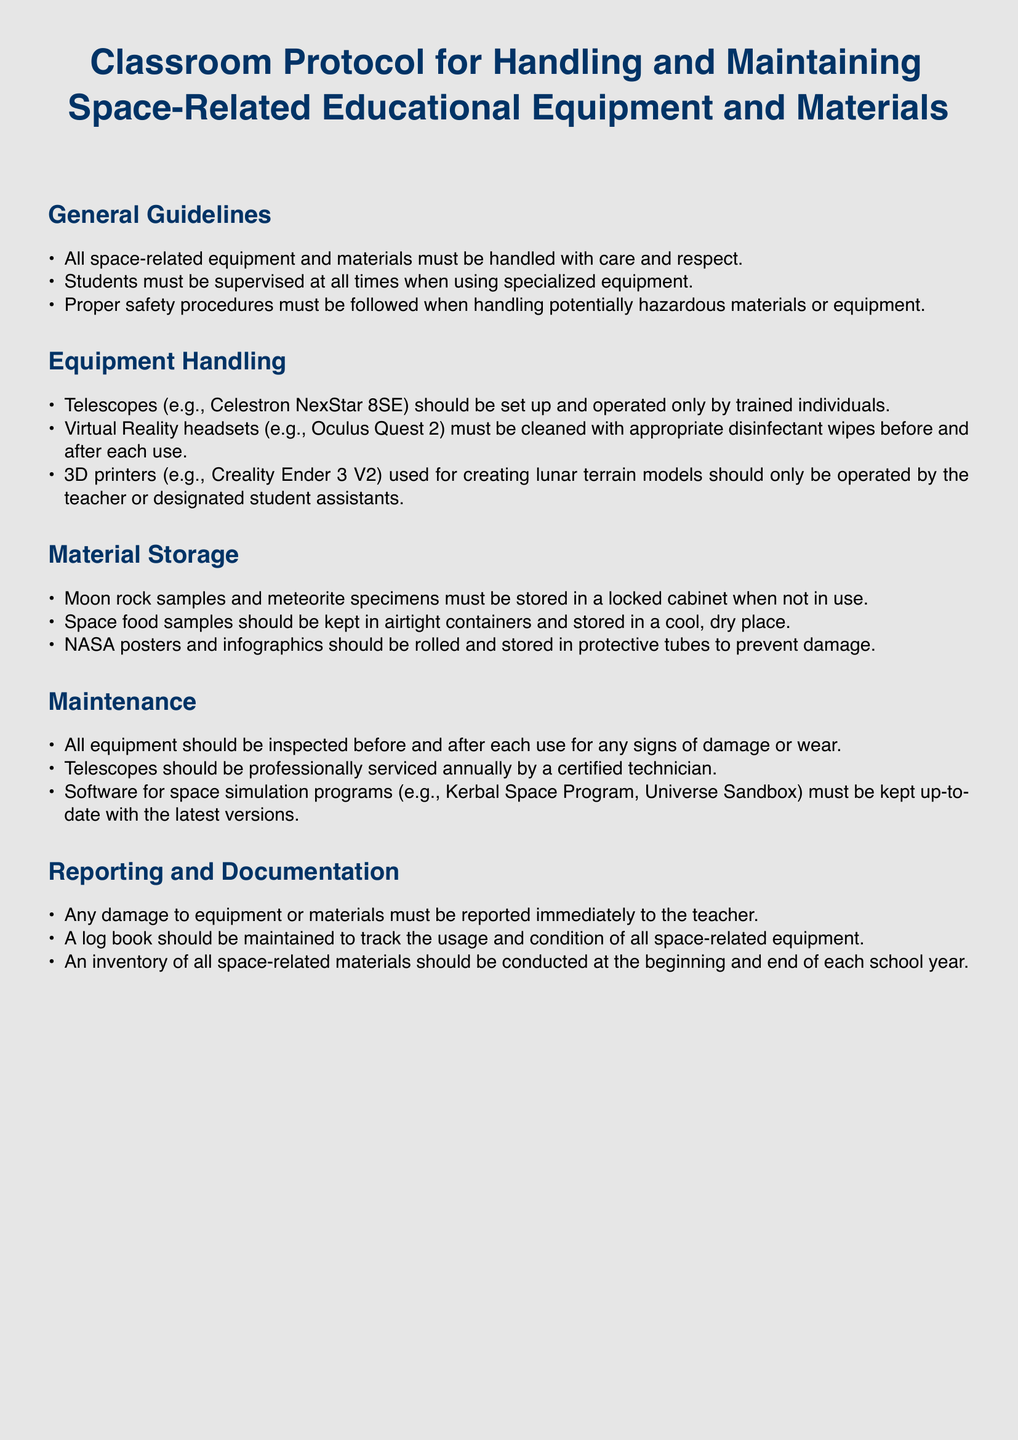What must be done after using Virtual Reality headsets? The document states that Virtual Reality headsets must be cleaned with appropriate disinfectant wipes before and after each use.
Answer: cleaned with appropriate disinfectant wipes Who should operate telescopes? The protocol specifies that telescopes should be set up and operated only by trained individuals.
Answer: trained individuals Where should moon rock samples be stored? According to the document, moon rock samples must be stored in a locked cabinet when not in use.
Answer: locked cabinet How often should telescopes be serviced? The maintenance section indicates that telescopes should be professionally serviced annually by a certified technician.
Answer: annually What type of containers should space food samples be kept in? The document instructs that space food samples should be kept in airtight containers.
Answer: airtight containers What must be reported immediately to the teacher? Any damage to equipment or materials must be reported immediately to the teacher.
Answer: damage to equipment or materials When should an inventory of space-related materials be conducted? The protocol states that an inventory should be conducted at the beginning and end of each school year.
Answer: beginning and end of each school year Who can use 3D printers for creating lunar terrain models? The document specifies that 3D printers should only be operated by the teacher or designated student assistants.
Answer: teacher or designated student assistants 